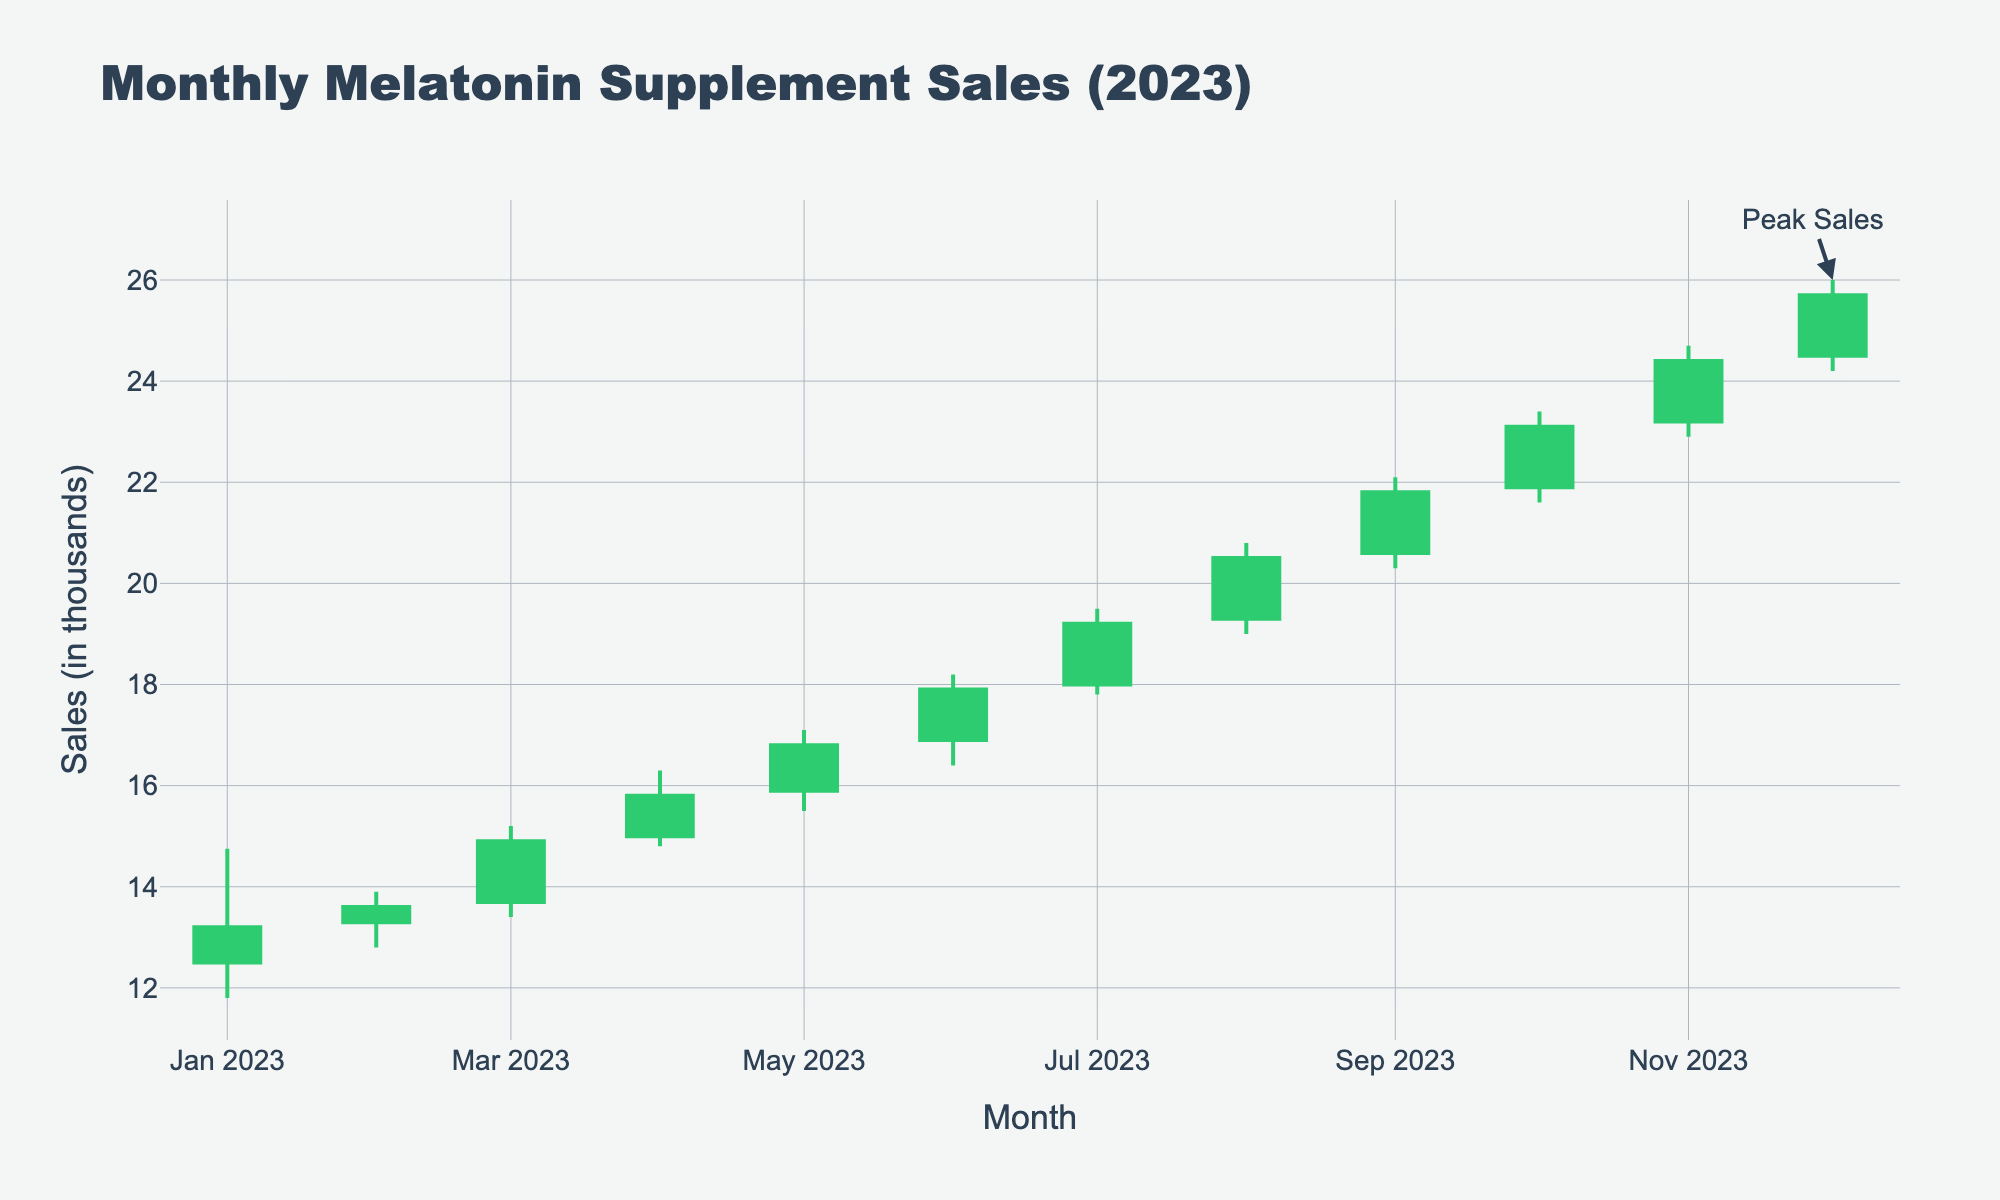What is the title of the chart? The title of the chart is usually displayed prominently at the top of the chart. In this case, it is "Monthly Melatonin Supplement Sales (2023)."
Answer: Monthly Melatonin Supplement Sales (2023) What is the highest sales value recorded in 2023? The highest sales value is found by looking at the "High" points on the chart. According to the data, the highest value recorded is in December with a high of 26.00.
Answer: 26.00 Which month had the lowest "Open" sales value, and what was it? The lowest "Open" sales value can be identified by examining the "Open" values for each month. January has the lowest value with an "Open" of 12.50.
Answer: January; 12.50 What is the trend of the sales across the year? The overall trend can be understood by noting the progression of the "Open" and "Close" values across the months. Sales generally increased throughout the year, moving from lower values in January to higher values in December.
Answer: Increasing trend What is the difference between the "High" and "Low" values for June 2023? To find the difference, subtract the "Low" value from the "High" value for June. The "High" is 18.20 and the "Low" is 16.40. Therefore, the difference is 18.20 - 16.40 = 1.80.
Answer: 1.80 Which month shows the highest fluctuation in sales and what is the difference between its highest and lowest values? The highest fluctuation is determined by finding the largest difference between "High" and "Low" values. December has the highest fluctuation with a difference of 26.00 - 24.20 = 1.80.
Answer: December; 1.80 How do the sales in October compare to those in August in terms of the "Close" values? By comparing the "Close" values, we can see that October has a "Close" value of 23.10, and August has a "Close" value of 20.50. Hence, October's "Close" value is higher than August's.
Answer: October's Close is higher Is there a month where the "Close" value is the same as the "Open" value? By examining the "Open" and "Close" values, we can determine whether any month has the same values. In the data provided, no month has matching "Open" and "Close" values.
Answer: No During which month did the sales open at the highest value, and what was that value? The highest "Open" value can be found by comparing all the "Open" values. December has the highest "Open" value of 24.50.
Answer: December; 24.50 